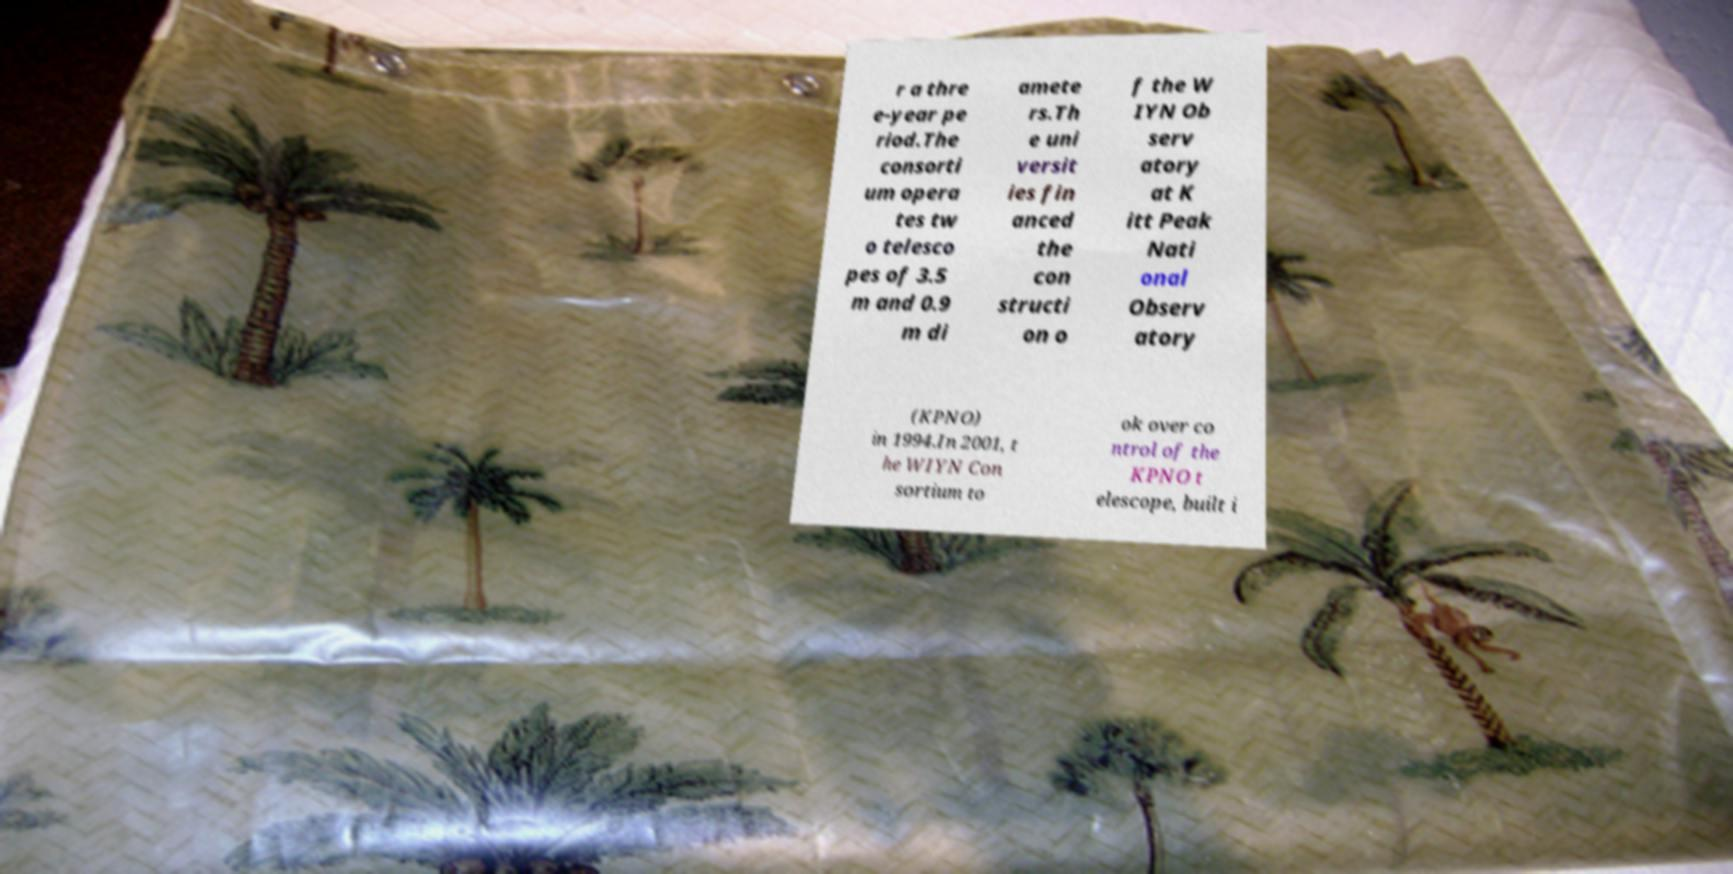Can you read and provide the text displayed in the image?This photo seems to have some interesting text. Can you extract and type it out for me? r a thre e-year pe riod.The consorti um opera tes tw o telesco pes of 3.5 m and 0.9 m di amete rs.Th e uni versit ies fin anced the con structi on o f the W IYN Ob serv atory at K itt Peak Nati onal Observ atory (KPNO) in 1994.In 2001, t he WIYN Con sortium to ok over co ntrol of the KPNO t elescope, built i 